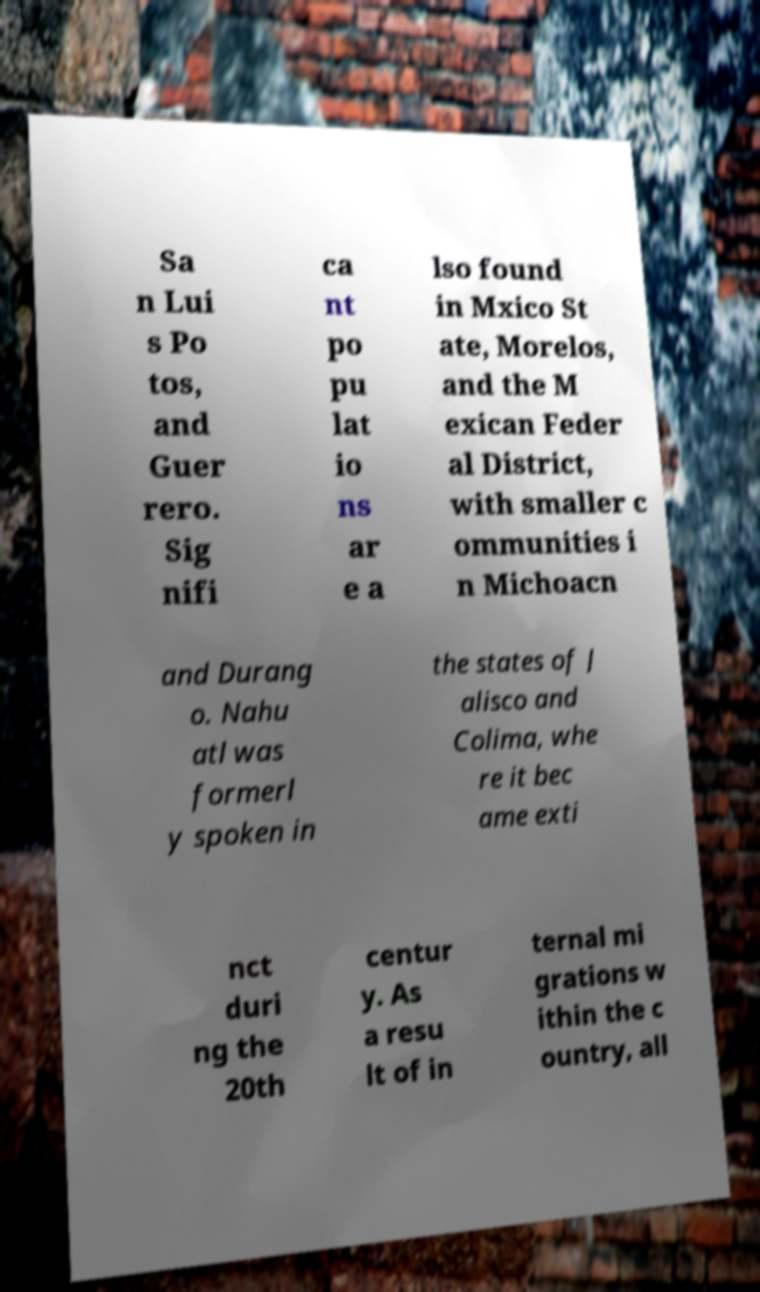Can you accurately transcribe the text from the provided image for me? Sa n Lui s Po tos, and Guer rero. Sig nifi ca nt po pu lat io ns ar e a lso found in Mxico St ate, Morelos, and the M exican Feder al District, with smaller c ommunities i n Michoacn and Durang o. Nahu atl was formerl y spoken in the states of J alisco and Colima, whe re it bec ame exti nct duri ng the 20th centur y. As a resu lt of in ternal mi grations w ithin the c ountry, all 